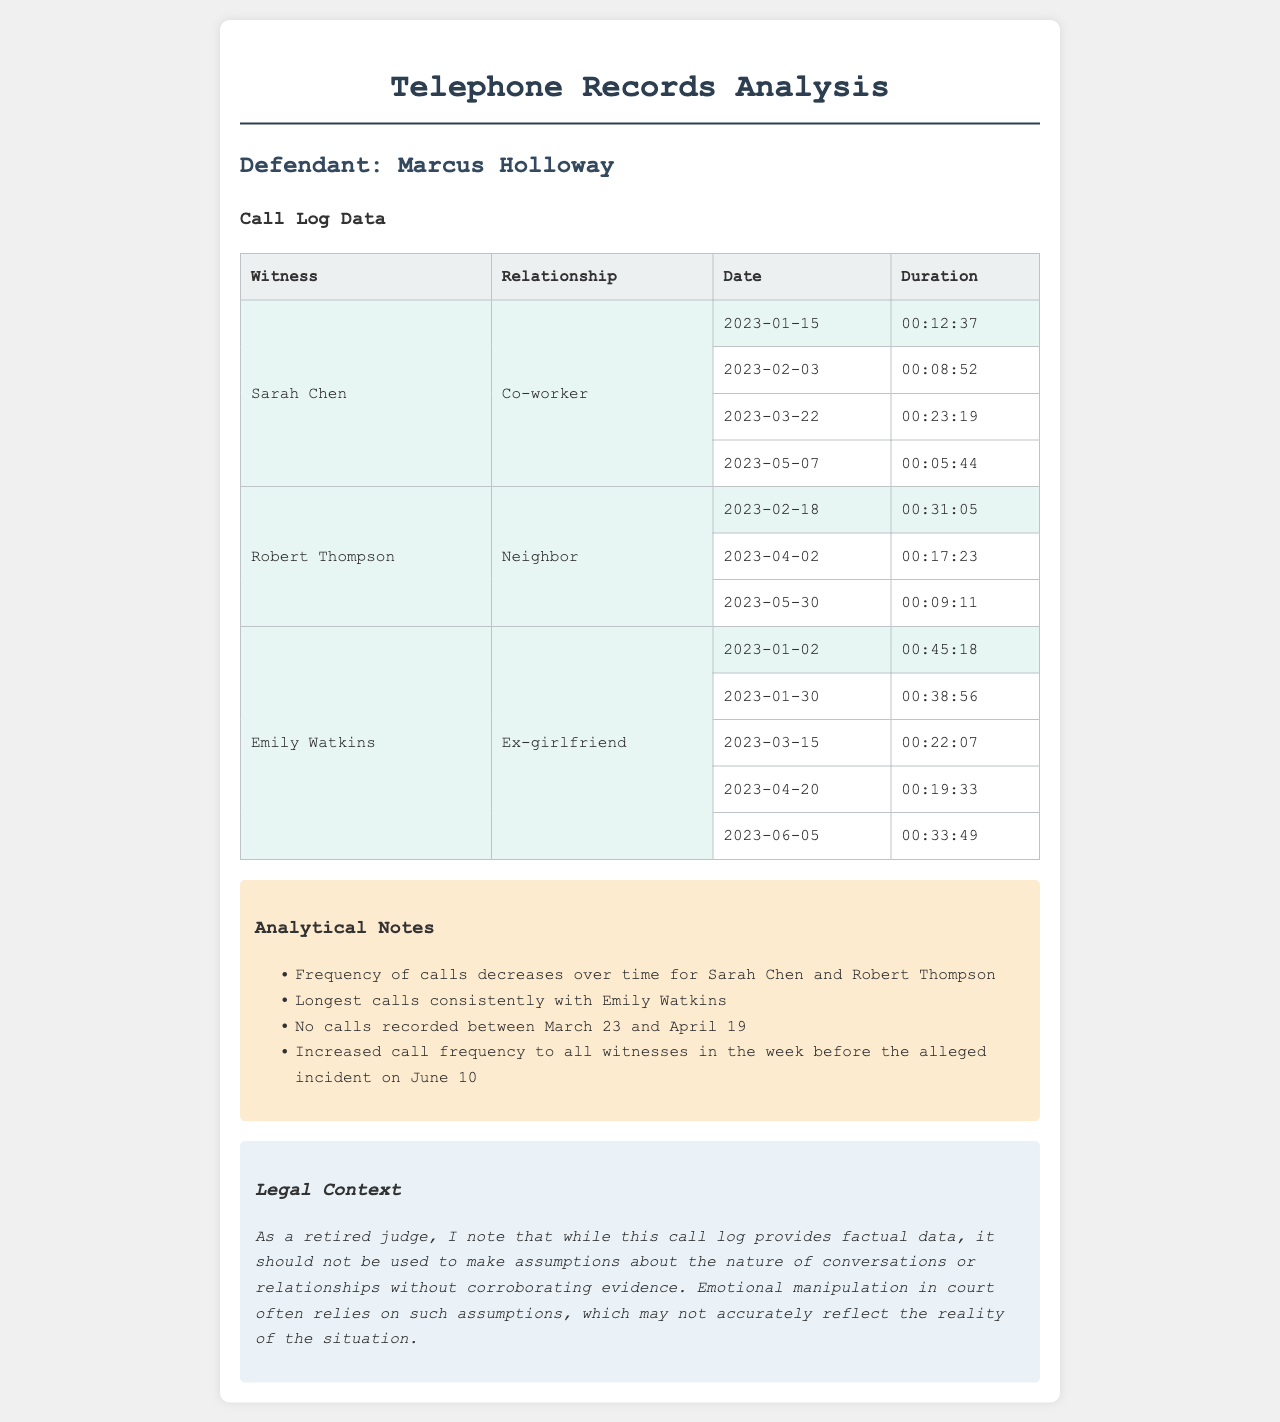What is the longest call duration? The longest call duration listed in the call log is 00:45:18 for the call made to Emily Watkins.
Answer: 00:45:18 How many calls were made to Sarah Chen? There are four calls recorded to Sarah Chen within the call log.
Answer: 4 What is the relationship of Robert Thompson to the defendant? Robert Thompson is noted as a neighbor in the call log.
Answer: Neighbor Which witness received calls on 2023-06-05? The call made on 2023-06-05 was to Emily Watkins.
Answer: Emily Watkins How many total calls were made during the month of February? There were four calls made in February; two to Sarah Chen and two to Robert Thompson.
Answer: 4 What pattern is observed in the frequency of calls to witnesses over time? The frequency of calls to witnesses generally decreases over time, especially for Sarah Chen and Robert Thompson.
Answer: Decreases Which witness had the most frequent communication with the defendant? Emily Watkins had the most frequent communication, with a total of five calls.
Answer: Emily Watkins When was the call with the shortest duration made? The shortest call duration of 00:05:44 was made on 2023-05-07.
Answer: 2023-05-07 What significant time period shows no recorded calls? The period between March 23 and April 19 shows no recorded calls.
Answer: March 23 to April 19 